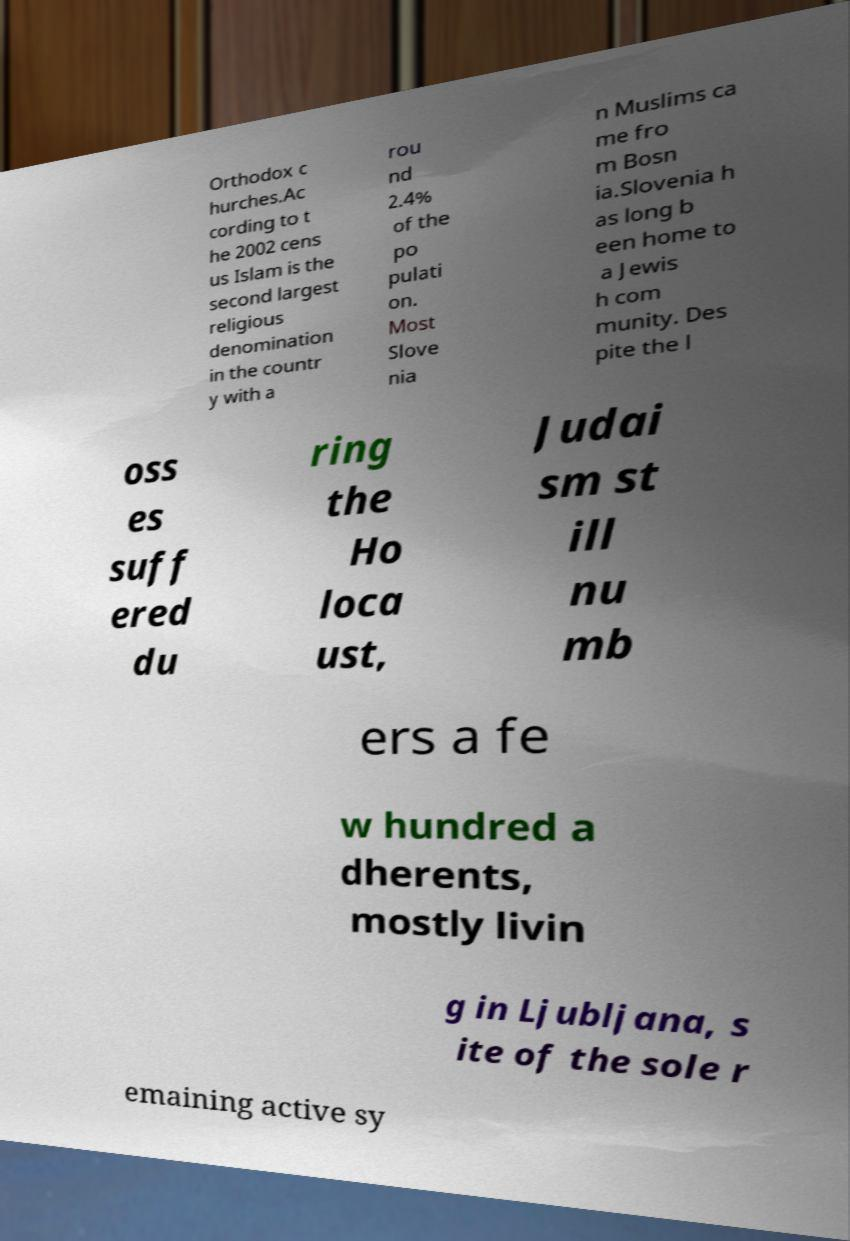Please identify and transcribe the text found in this image. Orthodox c hurches.Ac cording to t he 2002 cens us Islam is the second largest religious denomination in the countr y with a rou nd 2.4% of the po pulati on. Most Slove nia n Muslims ca me fro m Bosn ia.Slovenia h as long b een home to a Jewis h com munity. Des pite the l oss es suff ered du ring the Ho loca ust, Judai sm st ill nu mb ers a fe w hundred a dherents, mostly livin g in Ljubljana, s ite of the sole r emaining active sy 